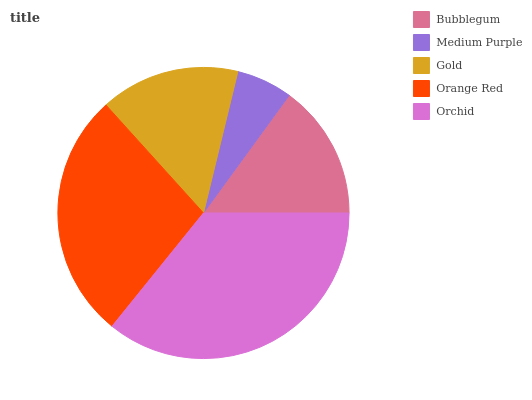Is Medium Purple the minimum?
Answer yes or no. Yes. Is Orchid the maximum?
Answer yes or no. Yes. Is Gold the minimum?
Answer yes or no. No. Is Gold the maximum?
Answer yes or no. No. Is Gold greater than Medium Purple?
Answer yes or no. Yes. Is Medium Purple less than Gold?
Answer yes or no. Yes. Is Medium Purple greater than Gold?
Answer yes or no. No. Is Gold less than Medium Purple?
Answer yes or no. No. Is Gold the high median?
Answer yes or no. Yes. Is Gold the low median?
Answer yes or no. Yes. Is Orange Red the high median?
Answer yes or no. No. Is Orange Red the low median?
Answer yes or no. No. 